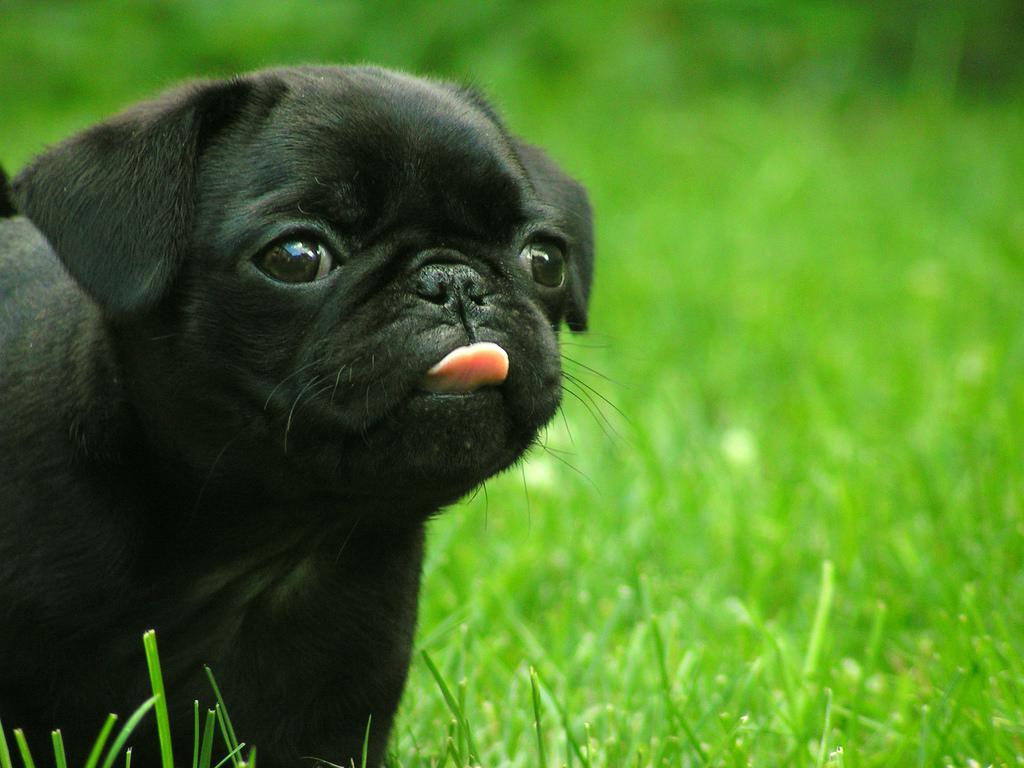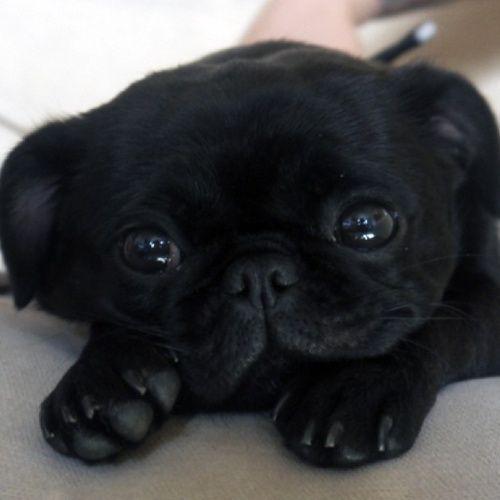The first image is the image on the left, the second image is the image on the right. Considering the images on both sides, is "There are exactly two dogs on the grass in the image on the right." valid? Answer yes or no. No. The first image is the image on the left, the second image is the image on the right. For the images shown, is this caption "Two dogs are sitting in the grass in one of the images." true? Answer yes or no. No. 